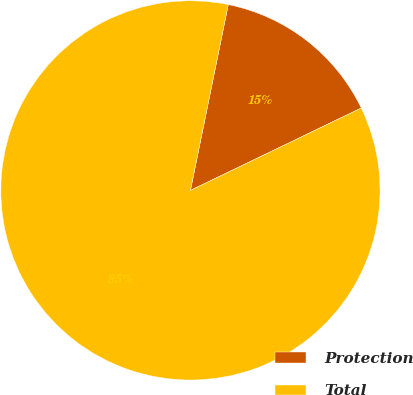Convert chart to OTSL. <chart><loc_0><loc_0><loc_500><loc_500><pie_chart><fcel>Protection<fcel>Total<nl><fcel>14.65%<fcel>85.35%<nl></chart> 